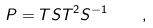<formula> <loc_0><loc_0><loc_500><loc_500>P = T { S } T ^ { 2 } { S } ^ { - 1 } \quad ,</formula> 